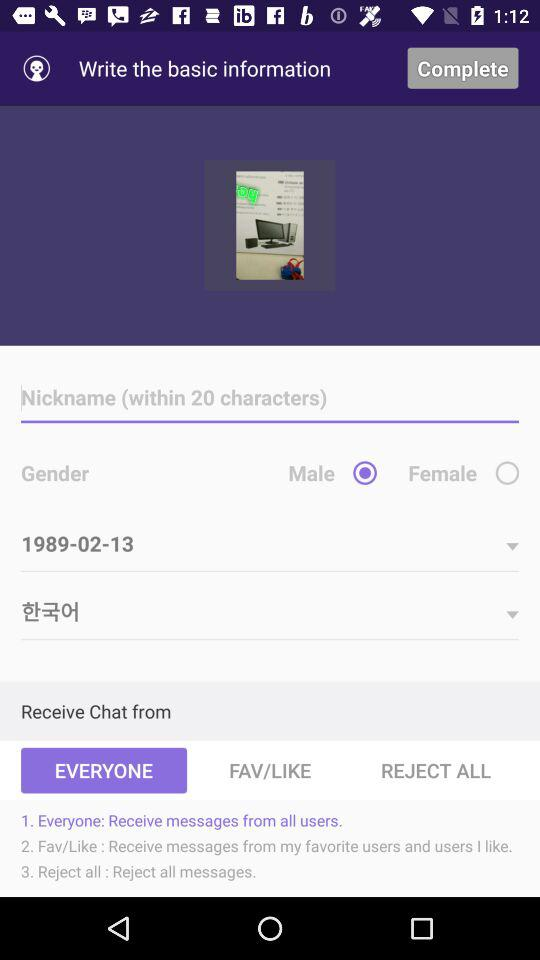What tab is selected to receive a chat from? The selected tab is "EVERYONE". 